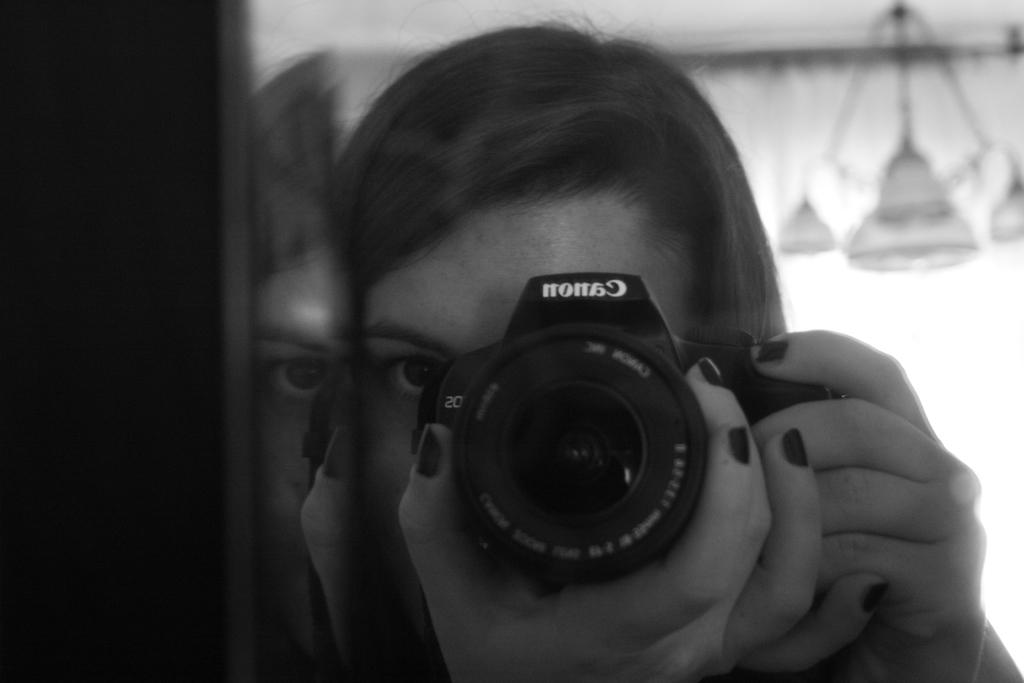Who is the main subject in the image? There is a woman in the image. What is the woman holding in the image? The woman is holding a camera. What type of insurance does the zebra in the image have? There is no zebra present in the image, so it is not possible to determine what type of insurance it might have. 